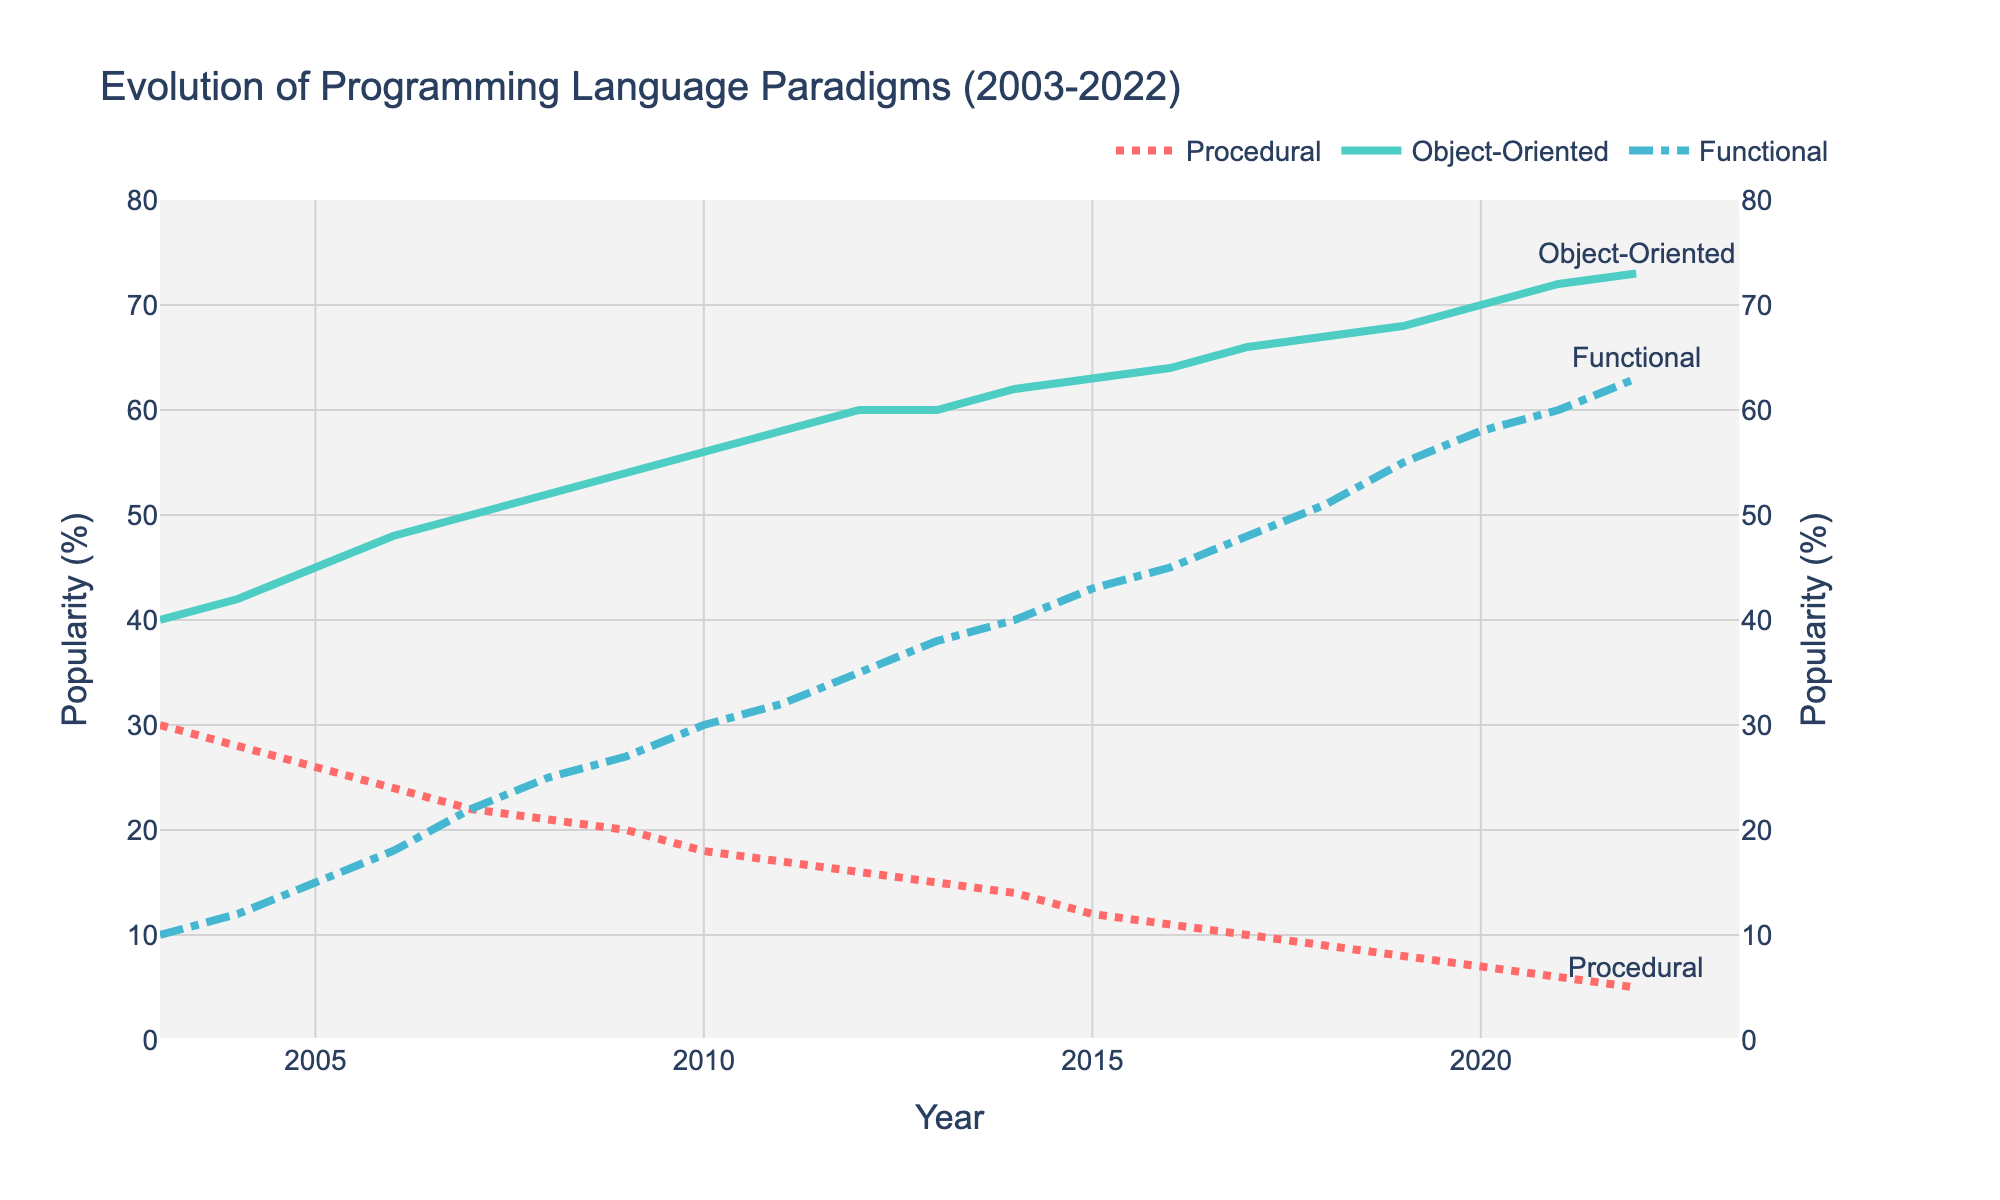What's the title of the figure? The title is typically placed at the top of the plot and represents the main topic being visualized. In this case, it is clearly indicated at the top center of the figure.
Answer: Evolution of Programming Language Paradigms (2003-2022) What does the x-axis represent? The x-axis at the bottom of the figure is labeled to indicate what information is plotted along the horizontal line. Here, it represents the years from 2003 to 2022.
Answer: Year What does the y-axis on the left side represent? The y-axis on the left side of the figure generally has units or labels to show what is being measured. In this plot, it is labeled "Popularity (%)" indicating the popularity percentage of programming paradigms.
Answer: Popularity (%) How does the popularity of the Procedural paradigm change over the period? By following the Procedural line from left to right, you can see the trend of its values decreasing from 30% in 2003 to 5% in 2022. This indicates a downward trend in the popularity of Procedural programming over the last two decades.
Answer: It decreases Which programming paradigm shows the highest popularity in 2022? By observing the values at the year 2022 on the x-axis and comparing the endpoints of the three lines, the Object-Oriented paradigm, reaching up to 73%, is the highest among the three.
Answer: Object-Oriented In which year did the popularity of Functional programming surpass 50%? By following the Functional line and checking the point where it reaches above 50%, it is clear that this occurs between 2017 and 2018. It solidly reaches 51% in 2018.
Answer: 2018 Which years showed no change in the popularity of Object-Oriented programming? By inspecting the year-to-year values for Object-Oriented, it's clear that values remain the same from 2012 to 2013, both at 60%.
Answer: 2012 to 2013 Compare the popularity changes between Object-Oriented and Functional paradigms from 2019 to 2022. The Object-Oriented paradigm increases from 68% in 2019 to 73% in 2022, showing an increase of 5%. For the Functional paradigm, it rises from 55% in 2019 to 63% in 2022, an increase of 8%.
Answer: Object-Oriented +5%, Functional +8% What is the difference in popularity between Object-Oriented and Procedural paradigms in 2007? In 2007, Object-Oriented is at 50% and Procedural is at 22%. The difference is calculated as 50% - 22%.
Answer: 28% Which paradigm had the least change in popularity from 2003 to 2022? By examining the lines and the initial and final values for each paradigm, the Procedural paradigm changes from 30% to 5%, a decrease of 25%; Object-Oriented changes from 40% to 73%, an increase of 33%; and Functional changes from 10% to 63%, an increase of 53%. Procedural has the smallest absolute value of change.
Answer: Procedural 